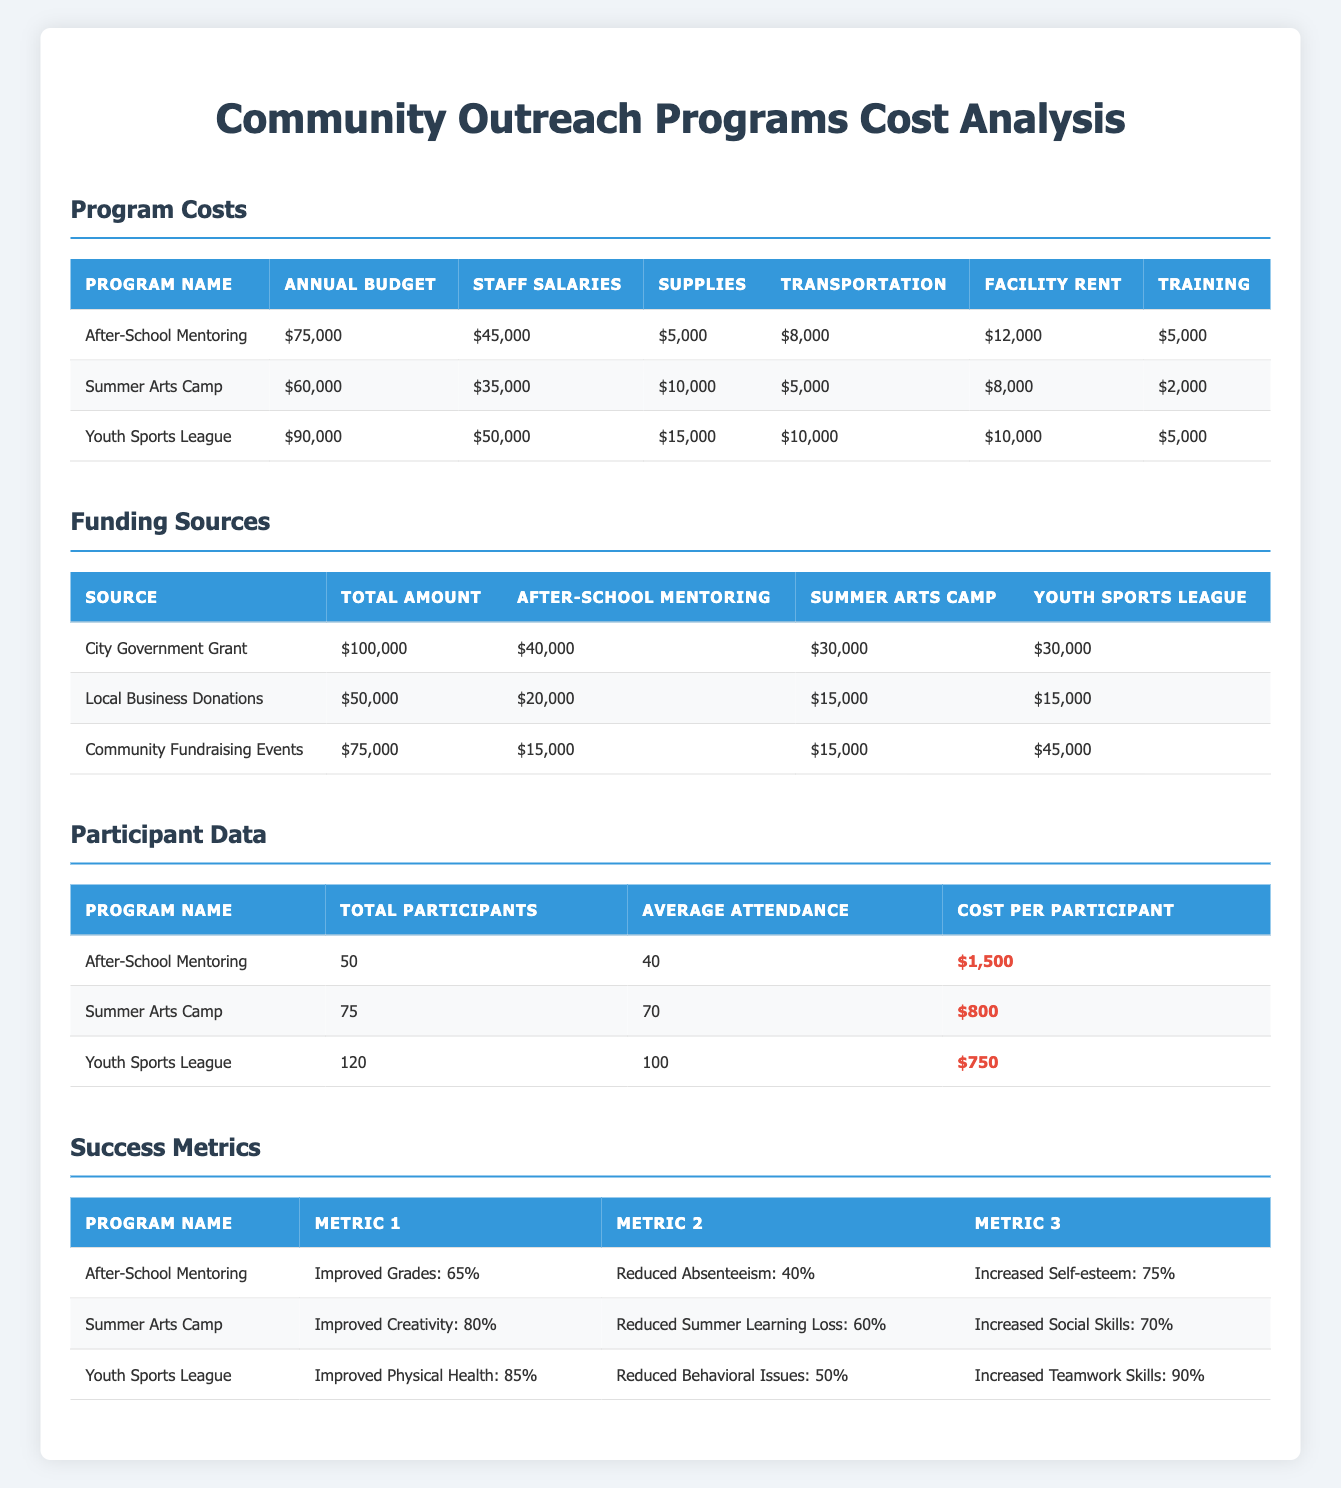What is the annual budget for the Youth Sports League? The table of program costs indicates that the annual budget for the Youth Sports League is $90,000.
Answer: $90,000 How much total funding does the City Government Grant provide? According to the funding sources table, the total amount provided by the City Government Grant is $100,000.
Answer: $100,000 Which program has the highest cost per participant? By reviewing the participant data table, the After-School Mentoring program has a cost per participant of $1,500, which is the highest when compared to the other programs.
Answer: After-School Mentoring What is the total cost of supplies for all three programs combined? The cost of supplies for each program is $5,000 for After-School Mentoring, $10,000 for Summer Arts Camp, and $15,000 for Youth Sports League. Adding them together gives $5,000 + $10,000 + $15,000 = $30,000.
Answer: $30,000 Did the Youth Sports League report an increase in teamwork skills? The success metrics for the Youth Sports League show an increased teamwork skills percentage of 90%. Therefore, it did report an increase.
Answer: Yes What is the average cost per participant across all programs? The cost per participant for After-School Mentoring is $1,500, for Summer Arts Camp is $800, and for Youth Sports League is $750. Calculating the average gives ($1,500 + $800 + $750) / 3 = $1,016.67.
Answer: $1,016.67 How much funding did the Summer Arts Camp receive from Community Fundraising Events? The funding sources table shows that the Summer Arts Camp received $15,000 from Community Fundraising Events.
Answer: $15,000 What is the total annual budget for After-School Mentoring and Summer Arts Camp? The annual budget for After-School Mentoring is $75,000, and for Summer Arts Camp is $60,000. Adding these amounts gives $75,000 + $60,000 = $135,000.
Answer: $135,000 Is the rate of reduced absenteeism for After-School Mentoring higher than that for Summer Arts Camp? The data indicates that After-School Mentoring has a reduced absenteeism rate of 40%, while Summer Arts Camp's rate is not provided. Since we cannot compare it directly to a numeric value, the answer is undetermined.
Answer: Cannot determine 